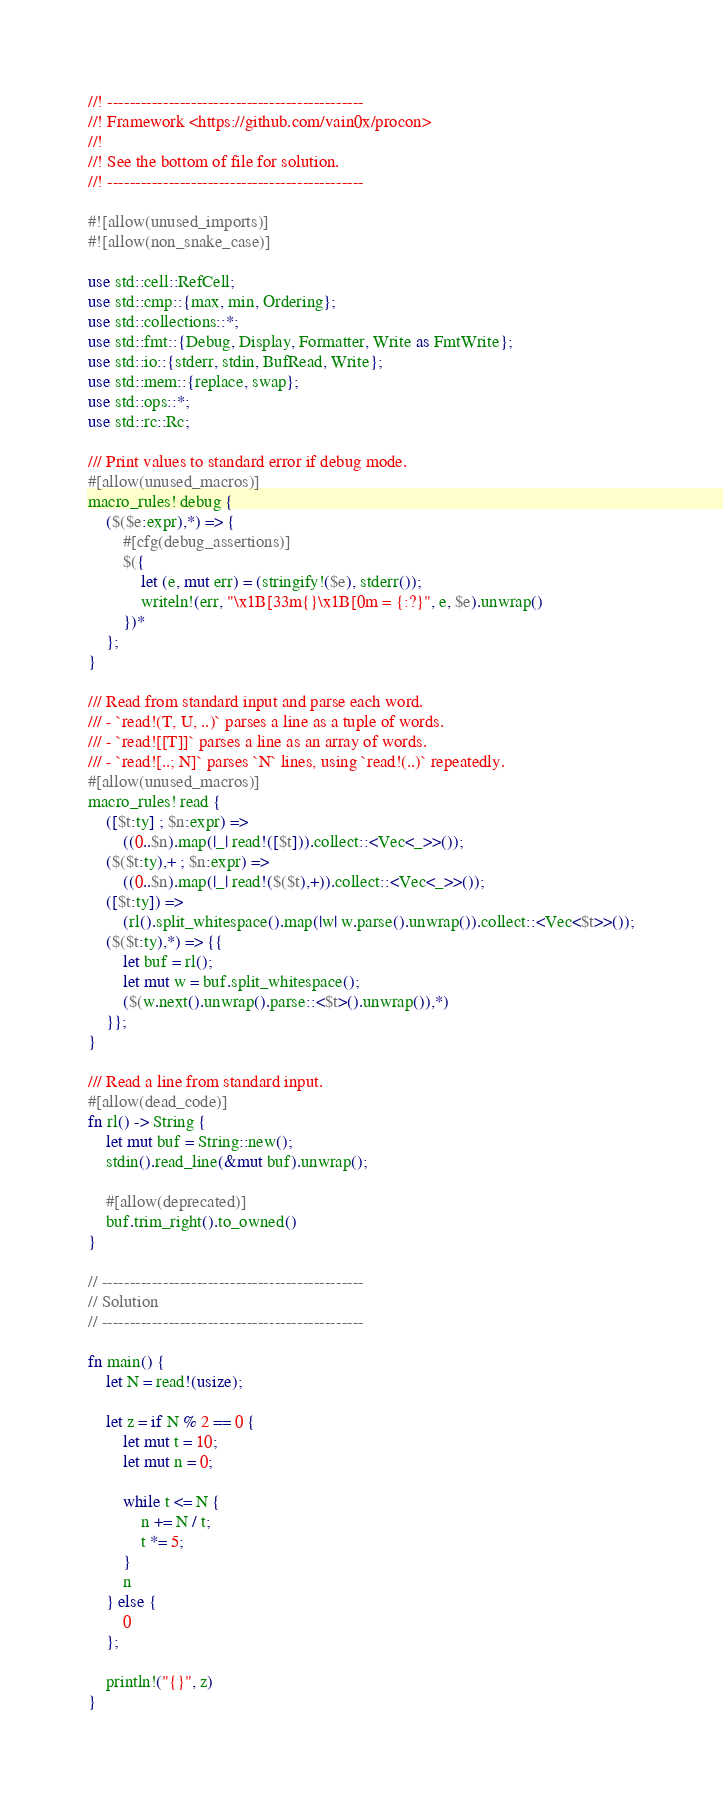<code> <loc_0><loc_0><loc_500><loc_500><_Rust_>//! ----------------------------------------------
//! Framework <https://github.com/vain0x/procon>
//!
//! See the bottom of file for solution.
//! ----------------------------------------------

#![allow(unused_imports)]
#![allow(non_snake_case)]

use std::cell::RefCell;
use std::cmp::{max, min, Ordering};
use std::collections::*;
use std::fmt::{Debug, Display, Formatter, Write as FmtWrite};
use std::io::{stderr, stdin, BufRead, Write};
use std::mem::{replace, swap};
use std::ops::*;
use std::rc::Rc;

/// Print values to standard error if debug mode.
#[allow(unused_macros)]
macro_rules! debug {
    ($($e:expr),*) => {
        #[cfg(debug_assertions)]
        $({
            let (e, mut err) = (stringify!($e), stderr());
            writeln!(err, "\x1B[33m{}\x1B[0m = {:?}", e, $e).unwrap()
        })*
    };
}

/// Read from standard input and parse each word.
/// - `read!(T, U, ..)` parses a line as a tuple of words.
/// - `read![[T]]` parses a line as an array of words.
/// - `read![..; N]` parses `N` lines, using `read!(..)` repeatedly.
#[allow(unused_macros)]
macro_rules! read {
    ([$t:ty] ; $n:expr) =>
        ((0..$n).map(|_| read!([$t])).collect::<Vec<_>>());
    ($($t:ty),+ ; $n:expr) =>
        ((0..$n).map(|_| read!($($t),+)).collect::<Vec<_>>());
    ([$t:ty]) =>
        (rl().split_whitespace().map(|w| w.parse().unwrap()).collect::<Vec<$t>>());
    ($($t:ty),*) => {{
        let buf = rl();
        let mut w = buf.split_whitespace();
        ($(w.next().unwrap().parse::<$t>().unwrap()),*)
    }};
}

/// Read a line from standard input.
#[allow(dead_code)]
fn rl() -> String {
    let mut buf = String::new();
    stdin().read_line(&mut buf).unwrap();

    #[allow(deprecated)]
    buf.trim_right().to_owned()
}

// -----------------------------------------------
// Solution
// -----------------------------------------------

fn main() {
    let N = read!(usize);

    let z = if N % 2 == 0 {
        let mut t = 10;
        let mut n = 0;

        while t <= N {
            n += N / t;
            t *= 5;
        }
        n
    } else {
        0
    };

    println!("{}", z)
}
</code> 